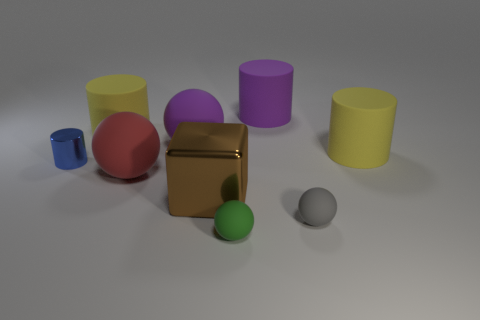What is the color of the tiny cylinder? blue 